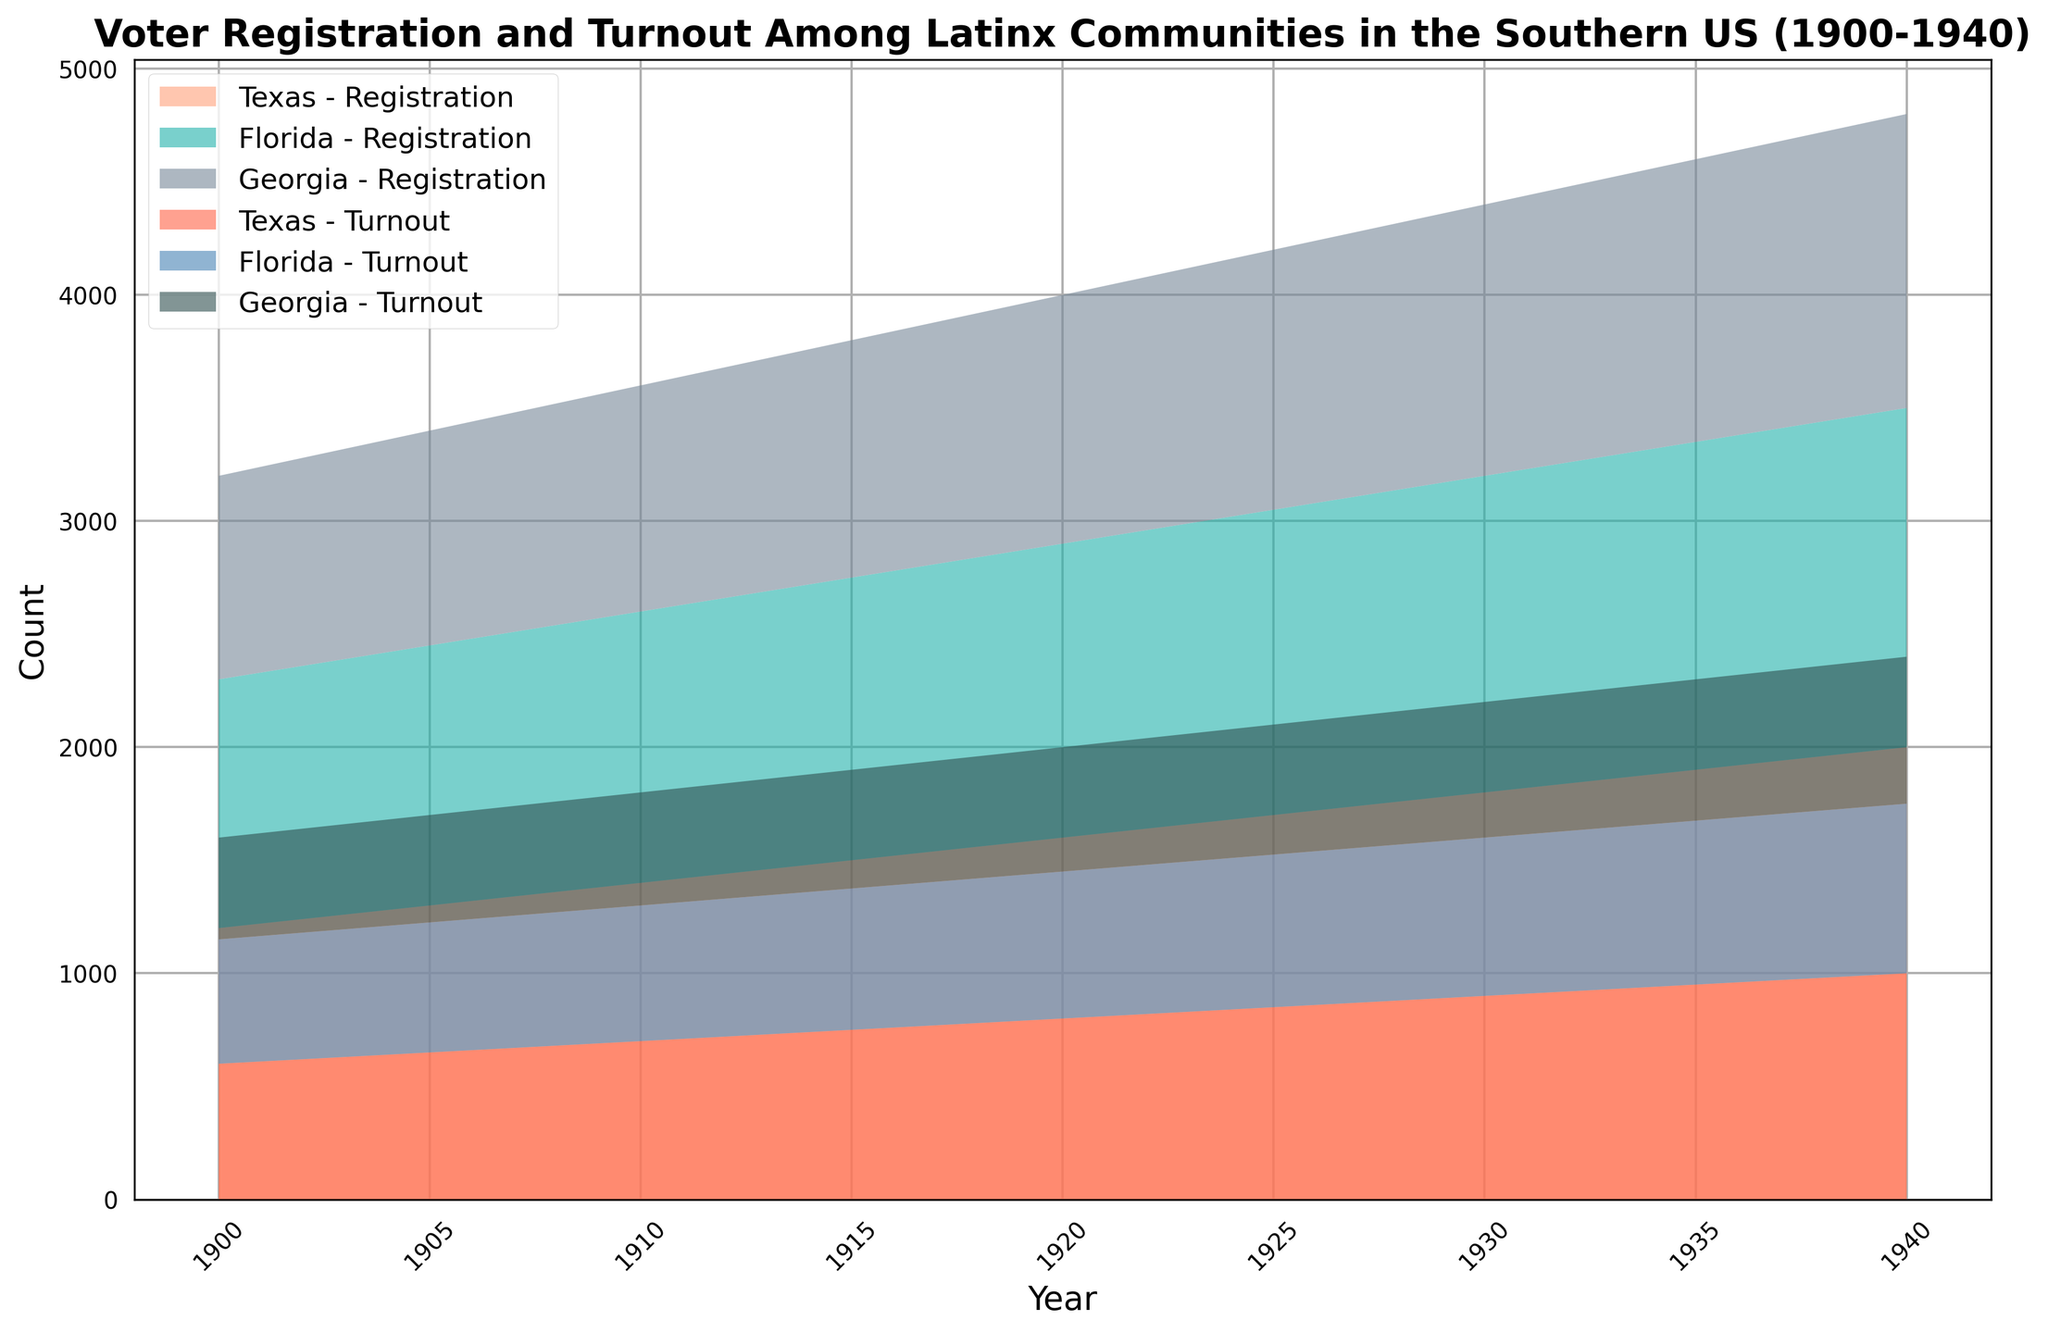Which state shows the highest voter registration among Latinx communities in 1940? By looking at the topmost layer in the registration section of the area chart for 1940, we observe that Texas has the highest voter registration.
Answer: Texas During which year does Florida's Latinx voter turnout reach 700? Focusing on the areas corresponding to Florida's voter turnout, we see that the value reaches 700 in the year 1930.
Answer: 1930 What is the overall trend of Latinx voter registration in Georgia from 1900 to 1940? Observing the area chart, the voter registration in Georgia shows a consistent upward trend throughout the period 1900 to 1940.
Answer: Upward trend How does voter turnout in Texas compare to that in Georgia in 1940? Comparing the heights of the voter turnout areas for Texas and Georgia in 1940, it is clear that Texas has significantly higher voter turnout.
Answer: Texas > Georgia What is the combined voter registration for Latinx communities across all states in 1925? Sum the voter registrations for Texas, Florida, and Georgia in 1925: 1700 (Texas) + 1350 (Florida) + 1150 (Georgia) = 4200.
Answer: 4200 Which year shows the smallest gap between voter registration and voter turnout for the Latinx community in Florida? By looking at the gap between the areas represented by voter registration and voter turnout of Florida across years, the smallest gap appears in 1940, where voter turnout is closest to registration.
Answer: 1940 When did Georgia's Latinx community first surpass 1000 in voter turnout? Checking the progression for Georgia’s voter turnout, it first surpasses 1000 voters in the year 1935.
Answer: 1935 How does the voter registration trend in Florida compare to the trend in Texas over the interval 1900-1940? Both states show a general upward trend in voter registration, but the rate of increase is steeper in Texas compared to Florida over these years.
Answer: Texas > Florida (rate of increase) What is the difference in voter turnout between Texas and Florida in 1920? From their respective areas in 1920, Texas has 800 voters and Florida has 650 voters, resulting in a difference of 800 - 650 = 150.
Answer: 150 In what year do all three states first register a voter turnout figure exceeding 500? Reviewing the chart, 1910 is the first year when Texas, Florida, and Georgia each have a voter turnout figure exceeding 500.
Answer: 1910 